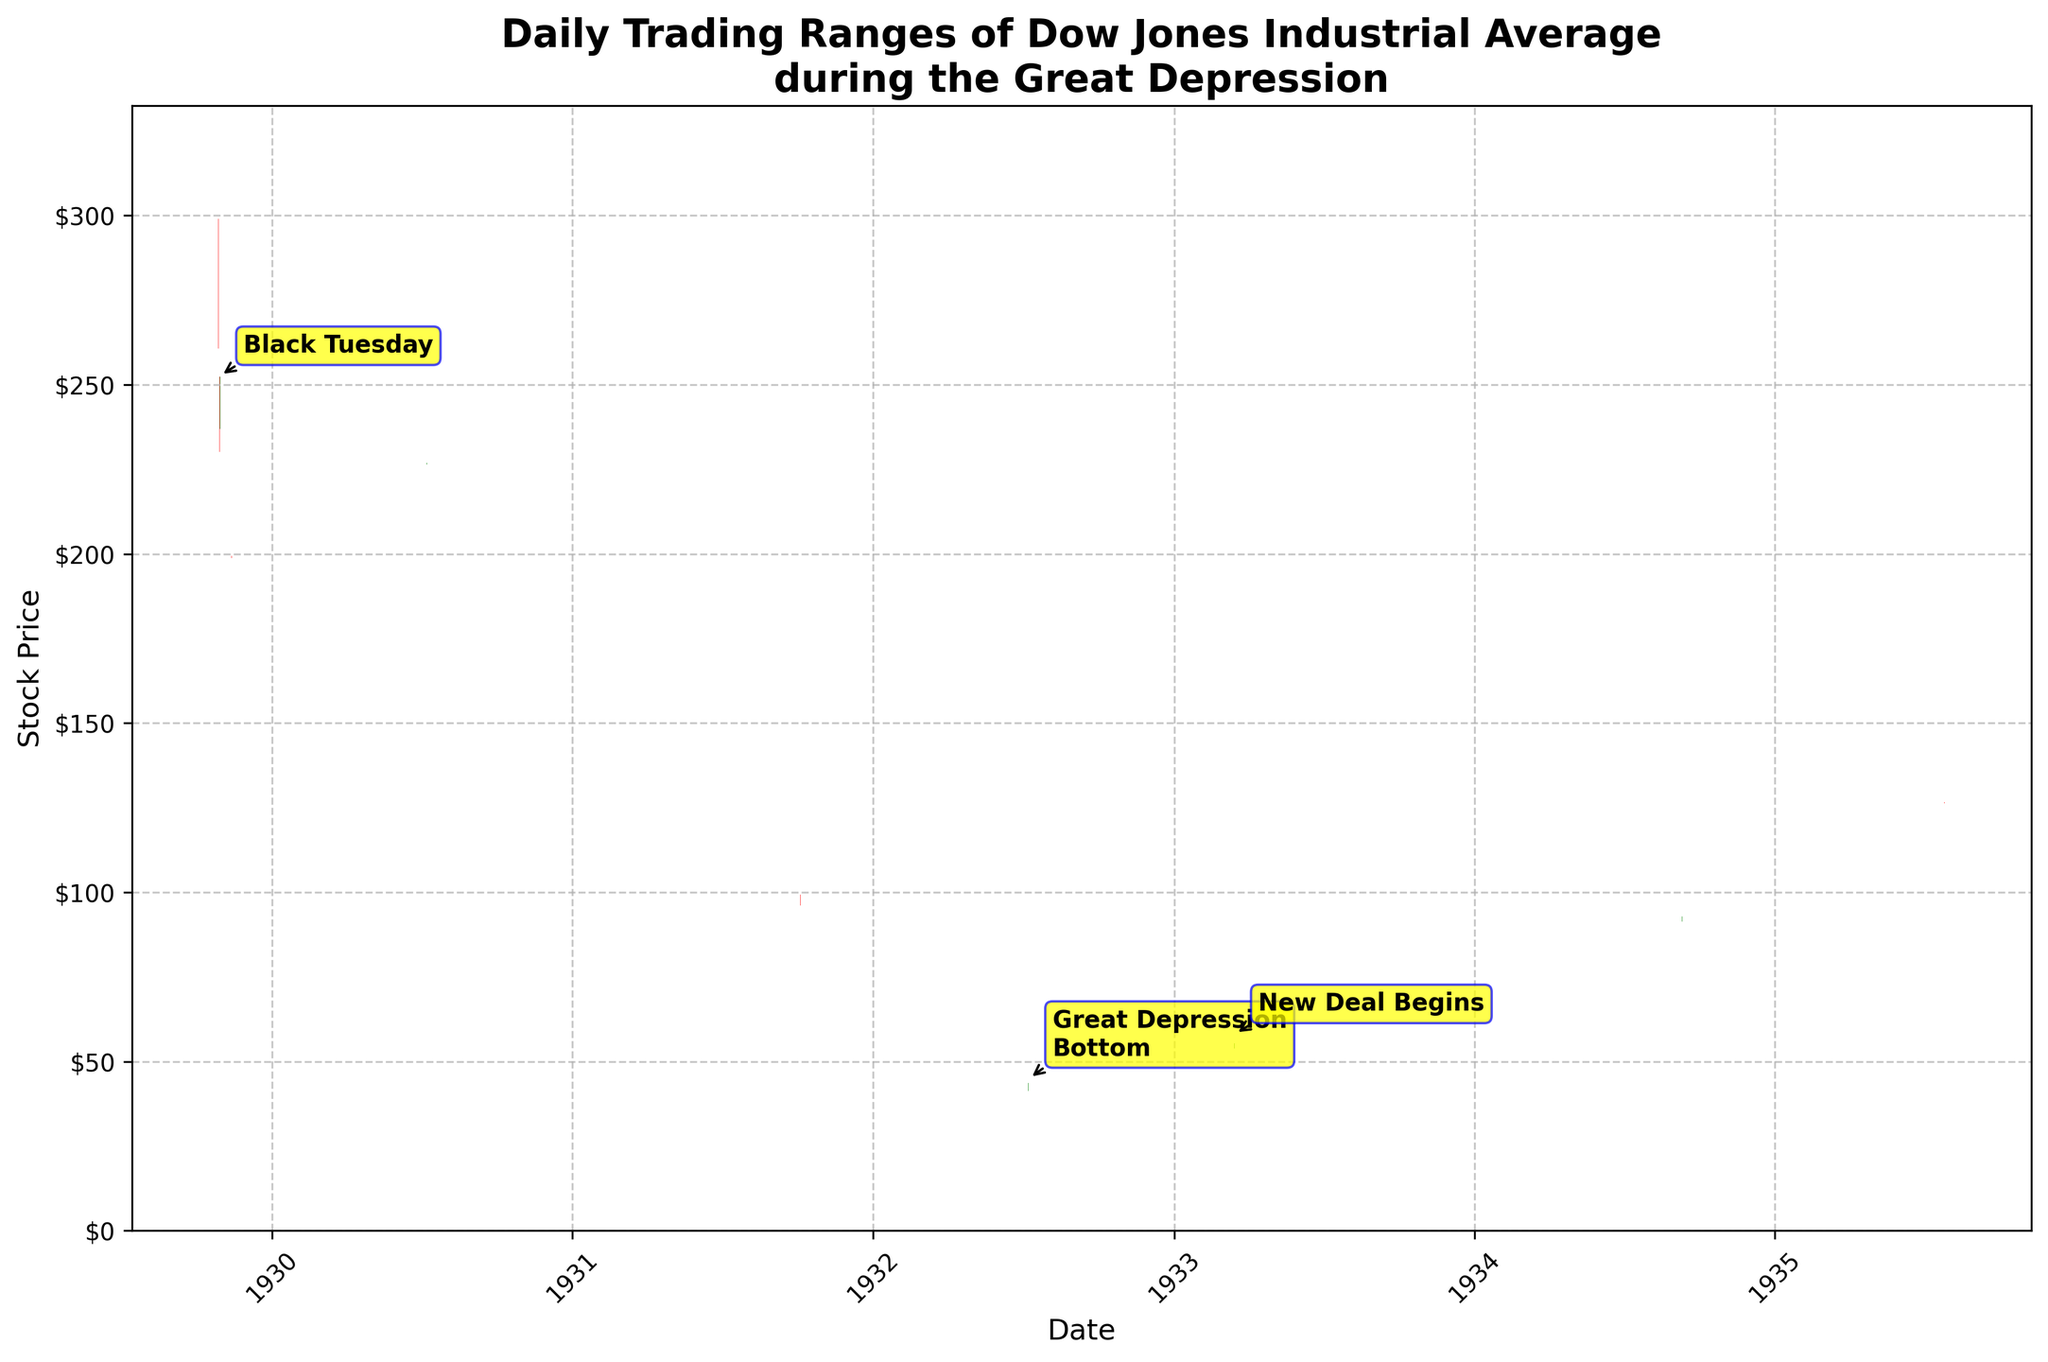What's the title of the plot? The title is displayed at the top of the figure in a larger font size and bold text.
Answer: Daily Trading Ranges of Dow Jones Industrial Average during the Great Depression What stock index is represented in this OHLC chart? The legend at the top of the chart indicates that the data is for the Dow Jones Industrial Average.
Answer: Dow Jones Industrial Average Which three key events during the Great Depression are annotated in the figure? The annotations are highlighted on specific dates with labels in yellow text boxes and arrows pointing to the events.
Answer: Black Tuesday, Great Depression Bottom, New Deal Begins On which date did the Dow Jones Industrial Average experience the lowest closing price? Locate the bar with the green color indicating the lowest value. Cross-reference the annotation or hover to find the corresponding date.
Answer: 1932-07-08 How can we tell if the closing price was higher or lower than the opening price on a given date? Green bars indicate that the closing price is higher than the opening price, while red bars indicate that the closing price is lower than the opening price.
Answer: Green for higher, red for lower What was the highest stock price reached during the period shown in the plot? Look for the top part of the highest green or red bar, and read the value on the y-axis.
Answer: Approximately $302.15 Which event caused a significant market drop depicted on the chart? Notice the annotation of "Black Tuesday," which coincides with a large red bar indicating a significant market drop.
Answer: Black Tuesday What is the date range of the data in the chart? The x-axis shows the temporal range. The earliest and latest dates of the data can be seen on the far left and far right of the axis.
Answer: 1929-10-28 to 1935-07-26 Which year showed a notable increase in stock prices and is annotated in the chart? Observe the annotations and look for the term related to an improving condition or new policy.
Answer: 1933 On Black Tuesday, did the Dow Jones Industrial Average close higher or lower than it opened? Check the color of the bar on 1929-10-29 (annotated as Black Tuesday), which is red, indicating a lower close.
Answer: Lower 